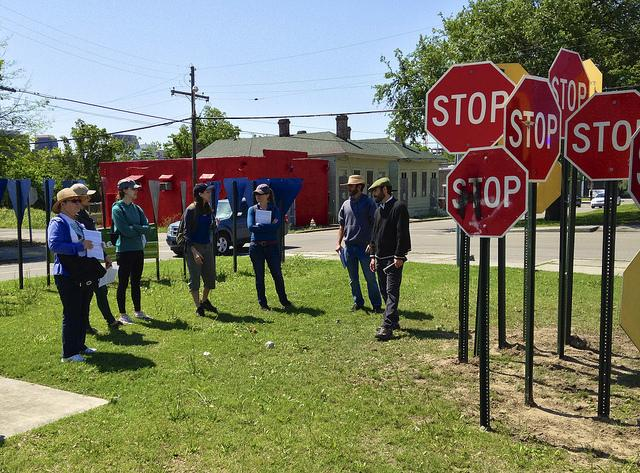Who created the works seen here?

Choices:
A) city planning
B) artist
C) government offices
D) traffic department artist 